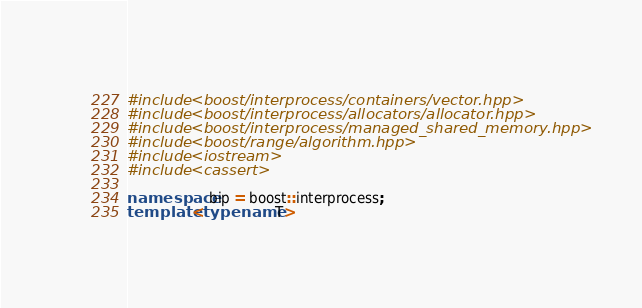<code> <loc_0><loc_0><loc_500><loc_500><_C++_>#include <boost/interprocess/containers/vector.hpp>
#include <boost/interprocess/allocators/allocator.hpp>
#include <boost/interprocess/managed_shared_memory.hpp>
#include <boost/range/algorithm.hpp>
#include <iostream>
#include <cassert>

namespace bip = boost::interprocess;
template <typename T> </code> 